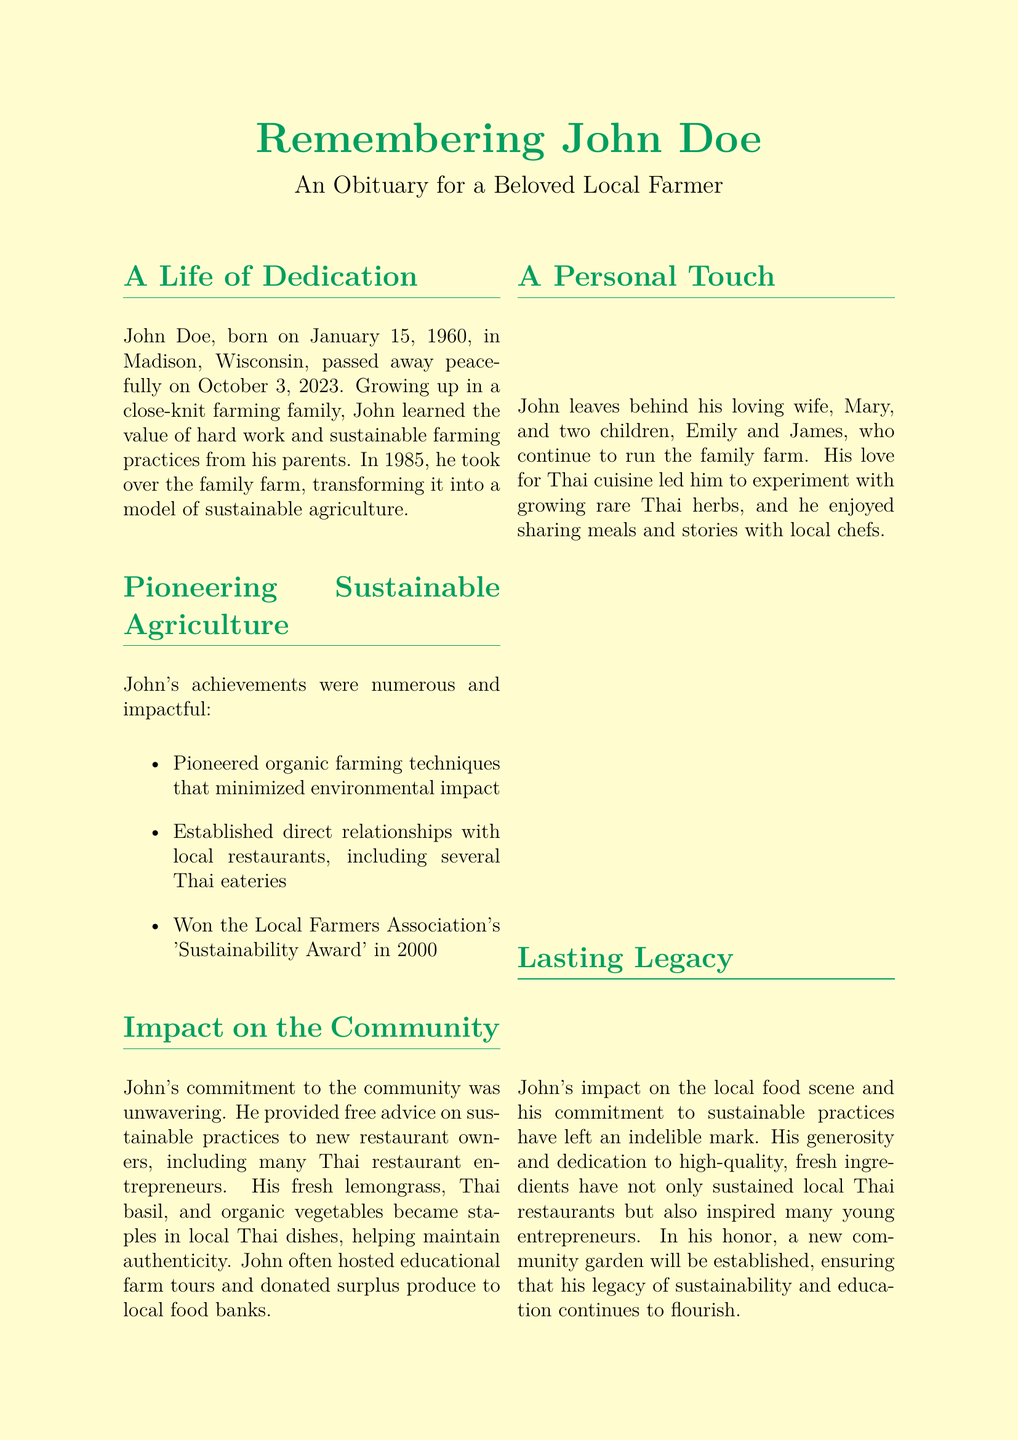What was John Doe's birth date? John Doe was born on January 15, 1960, as stated in the obituary.
Answer: January 15, 1960 What year did John take over the family farm? The document indicates that John took over the family farm in 1985.
Answer: 1985 Which award did John win in 2000? According to the obituary, John won the Local Farmers Association's 'Sustainability Award' in 2000.
Answer: Sustainability Award What types of herbs did John grow for Thai cuisine? The document mentions that John experimented with growing rare Thai herbs.
Answer: Rare Thai herbs What is the date and time of the memorial service? The obituary specifies the date and time of the memorial service as October 10, 2023, at 2:00 PM.
Answer: October 10, 2023, 2:00 PM How did John support new restaurant owners? The obituary states that John provided free advice on sustainable practices to new restaurant owners.
Answer: Free advice What is one way John contributed to the community? One contribution mentioned in the document is that John donated surplus produce to local food banks.
Answer: Donated surplus produce What phrase did John use about earth? The obituary includes a quote from John saying, "The earth does not belong to us. We belong to the earth."
Answer: The earth does not belong to us. We belong to the earth 